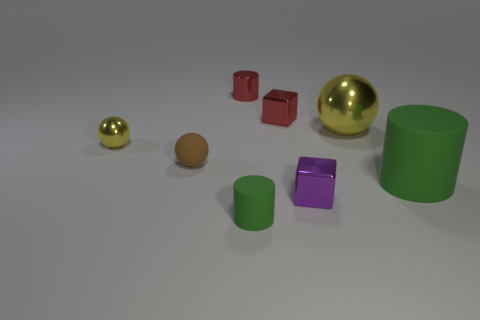Are there any other things that have the same size as the purple shiny object?
Your response must be concise. Yes. Are there more big metal things that are in front of the small yellow shiny sphere than large green cylinders that are to the left of the large green matte thing?
Provide a succinct answer. No. Does the green cylinder that is left of the purple shiny thing have the same size as the purple metal block?
Offer a very short reply. Yes. There is a green cylinder left of the block behind the small metallic sphere; what number of small yellow spheres are behind it?
Make the answer very short. 1. There is a cylinder that is in front of the small brown object and behind the tiny green matte object; how big is it?
Keep it short and to the point. Large. How many other objects are the same shape as the purple metal object?
Your answer should be compact. 1. There is a small purple thing; what number of shiny cylinders are in front of it?
Offer a very short reply. 0. Is the number of small brown things that are behind the large shiny sphere less than the number of shiny balls in front of the small brown ball?
Your response must be concise. No. What is the shape of the yellow shiny thing that is left of the tiny cylinder that is behind the tiny brown rubber sphere in front of the red cylinder?
Provide a short and direct response. Sphere. What is the shape of the shiny object that is in front of the large shiny ball and right of the small yellow thing?
Make the answer very short. Cube. 